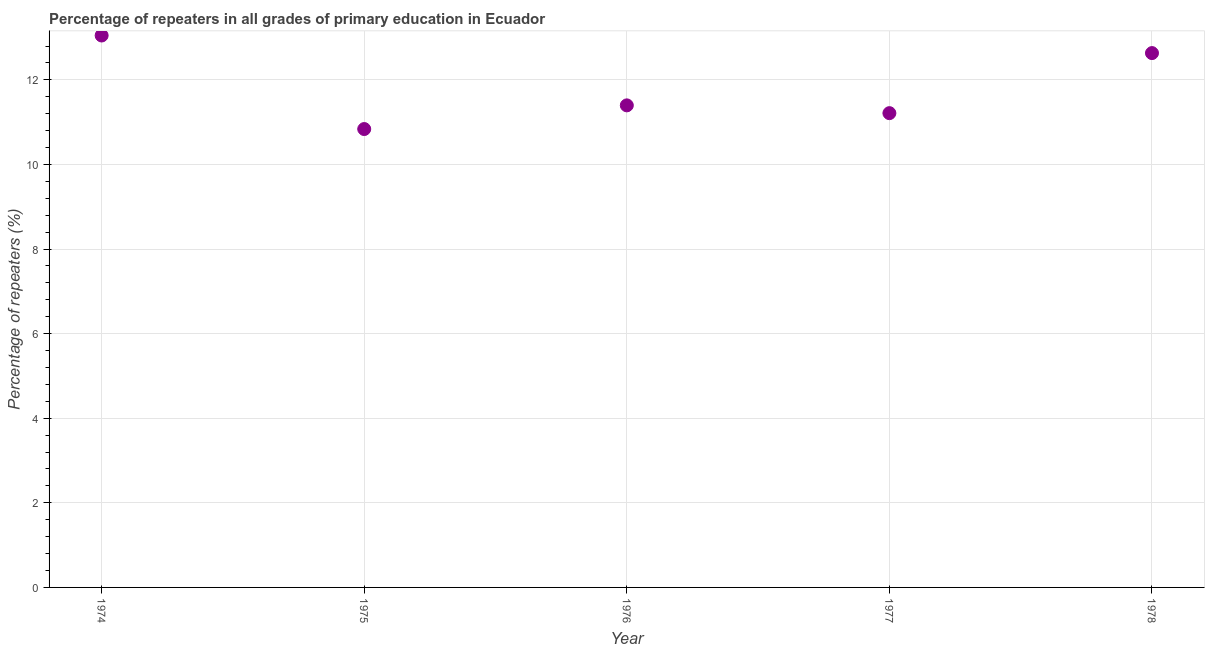What is the percentage of repeaters in primary education in 1975?
Ensure brevity in your answer.  10.84. Across all years, what is the maximum percentage of repeaters in primary education?
Offer a very short reply. 13.05. Across all years, what is the minimum percentage of repeaters in primary education?
Provide a succinct answer. 10.84. In which year was the percentage of repeaters in primary education maximum?
Give a very brief answer. 1974. In which year was the percentage of repeaters in primary education minimum?
Offer a very short reply. 1975. What is the sum of the percentage of repeaters in primary education?
Offer a terse response. 59.13. What is the difference between the percentage of repeaters in primary education in 1976 and 1978?
Offer a terse response. -1.24. What is the average percentage of repeaters in primary education per year?
Your answer should be very brief. 11.83. What is the median percentage of repeaters in primary education?
Your answer should be compact. 11.4. What is the ratio of the percentage of repeaters in primary education in 1977 to that in 1978?
Keep it short and to the point. 0.89. Is the percentage of repeaters in primary education in 1974 less than that in 1978?
Your answer should be very brief. No. Is the difference between the percentage of repeaters in primary education in 1976 and 1977 greater than the difference between any two years?
Provide a succinct answer. No. What is the difference between the highest and the second highest percentage of repeaters in primary education?
Your answer should be compact. 0.42. What is the difference between the highest and the lowest percentage of repeaters in primary education?
Your answer should be very brief. 2.21. In how many years, is the percentage of repeaters in primary education greater than the average percentage of repeaters in primary education taken over all years?
Offer a very short reply. 2. What is the difference between two consecutive major ticks on the Y-axis?
Give a very brief answer. 2. Does the graph contain grids?
Provide a succinct answer. Yes. What is the title of the graph?
Ensure brevity in your answer.  Percentage of repeaters in all grades of primary education in Ecuador. What is the label or title of the X-axis?
Provide a short and direct response. Year. What is the label or title of the Y-axis?
Your answer should be very brief. Percentage of repeaters (%). What is the Percentage of repeaters (%) in 1974?
Your response must be concise. 13.05. What is the Percentage of repeaters (%) in 1975?
Make the answer very short. 10.84. What is the Percentage of repeaters (%) in 1976?
Provide a short and direct response. 11.4. What is the Percentage of repeaters (%) in 1977?
Provide a succinct answer. 11.21. What is the Percentage of repeaters (%) in 1978?
Offer a very short reply. 12.63. What is the difference between the Percentage of repeaters (%) in 1974 and 1975?
Your answer should be very brief. 2.21. What is the difference between the Percentage of repeaters (%) in 1974 and 1976?
Your answer should be very brief. 1.65. What is the difference between the Percentage of repeaters (%) in 1974 and 1977?
Your answer should be very brief. 1.84. What is the difference between the Percentage of repeaters (%) in 1974 and 1978?
Your answer should be very brief. 0.42. What is the difference between the Percentage of repeaters (%) in 1975 and 1976?
Offer a terse response. -0.56. What is the difference between the Percentage of repeaters (%) in 1975 and 1977?
Provide a succinct answer. -0.38. What is the difference between the Percentage of repeaters (%) in 1975 and 1978?
Provide a succinct answer. -1.8. What is the difference between the Percentage of repeaters (%) in 1976 and 1977?
Provide a short and direct response. 0.18. What is the difference between the Percentage of repeaters (%) in 1976 and 1978?
Your response must be concise. -1.24. What is the difference between the Percentage of repeaters (%) in 1977 and 1978?
Provide a succinct answer. -1.42. What is the ratio of the Percentage of repeaters (%) in 1974 to that in 1975?
Make the answer very short. 1.2. What is the ratio of the Percentage of repeaters (%) in 1974 to that in 1976?
Give a very brief answer. 1.15. What is the ratio of the Percentage of repeaters (%) in 1974 to that in 1977?
Provide a short and direct response. 1.16. What is the ratio of the Percentage of repeaters (%) in 1974 to that in 1978?
Keep it short and to the point. 1.03. What is the ratio of the Percentage of repeaters (%) in 1975 to that in 1976?
Your answer should be compact. 0.95. What is the ratio of the Percentage of repeaters (%) in 1975 to that in 1978?
Make the answer very short. 0.86. What is the ratio of the Percentage of repeaters (%) in 1976 to that in 1977?
Give a very brief answer. 1.02. What is the ratio of the Percentage of repeaters (%) in 1976 to that in 1978?
Offer a very short reply. 0.9. What is the ratio of the Percentage of repeaters (%) in 1977 to that in 1978?
Provide a succinct answer. 0.89. 